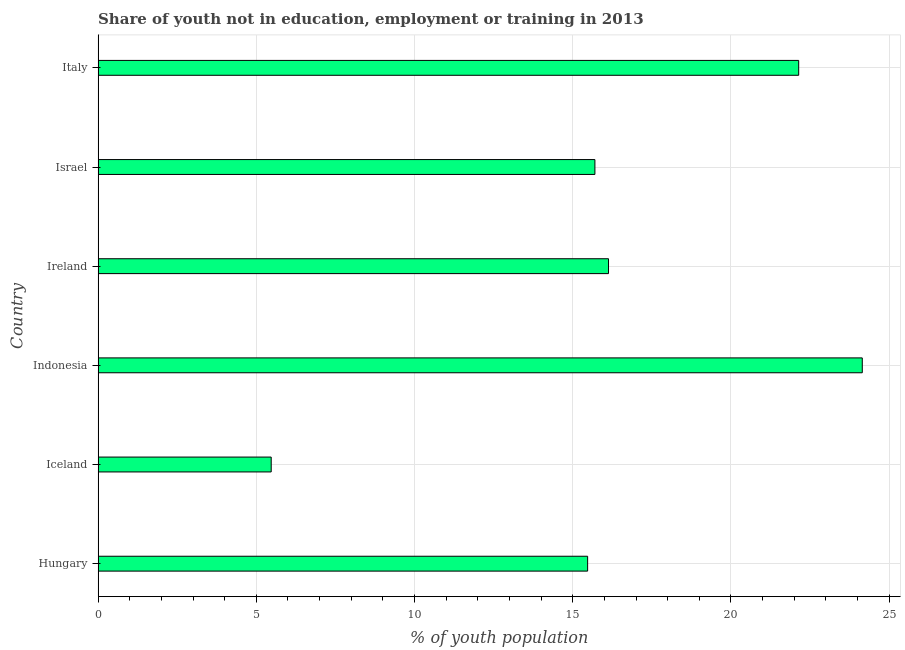What is the title of the graph?
Keep it short and to the point. Share of youth not in education, employment or training in 2013. What is the label or title of the X-axis?
Provide a succinct answer. % of youth population. What is the unemployed youth population in Italy?
Give a very brief answer. 22.14. Across all countries, what is the maximum unemployed youth population?
Your response must be concise. 24.15. Across all countries, what is the minimum unemployed youth population?
Give a very brief answer. 5.47. What is the sum of the unemployed youth population?
Keep it short and to the point. 99.06. What is the difference between the unemployed youth population in Indonesia and Italy?
Offer a terse response. 2.01. What is the average unemployed youth population per country?
Ensure brevity in your answer.  16.51. What is the median unemployed youth population?
Your answer should be very brief. 15.91. What is the ratio of the unemployed youth population in Ireland to that in Israel?
Your answer should be very brief. 1.03. Is the unemployed youth population in Hungary less than that in Indonesia?
Offer a very short reply. Yes. What is the difference between the highest and the second highest unemployed youth population?
Offer a very short reply. 2.01. What is the difference between the highest and the lowest unemployed youth population?
Your response must be concise. 18.68. Are all the bars in the graph horizontal?
Your answer should be compact. Yes. Are the values on the major ticks of X-axis written in scientific E-notation?
Your answer should be very brief. No. What is the % of youth population of Hungary?
Offer a very short reply. 15.47. What is the % of youth population of Iceland?
Your answer should be compact. 5.47. What is the % of youth population in Indonesia?
Provide a succinct answer. 24.15. What is the % of youth population in Ireland?
Offer a terse response. 16.13. What is the % of youth population in Israel?
Make the answer very short. 15.7. What is the % of youth population in Italy?
Your answer should be compact. 22.14. What is the difference between the % of youth population in Hungary and Iceland?
Provide a succinct answer. 10. What is the difference between the % of youth population in Hungary and Indonesia?
Provide a succinct answer. -8.68. What is the difference between the % of youth population in Hungary and Ireland?
Your response must be concise. -0.66. What is the difference between the % of youth population in Hungary and Israel?
Your answer should be compact. -0.23. What is the difference between the % of youth population in Hungary and Italy?
Offer a terse response. -6.67. What is the difference between the % of youth population in Iceland and Indonesia?
Your answer should be compact. -18.68. What is the difference between the % of youth population in Iceland and Ireland?
Give a very brief answer. -10.66. What is the difference between the % of youth population in Iceland and Israel?
Offer a terse response. -10.23. What is the difference between the % of youth population in Iceland and Italy?
Your answer should be compact. -16.67. What is the difference between the % of youth population in Indonesia and Ireland?
Your answer should be very brief. 8.02. What is the difference between the % of youth population in Indonesia and Israel?
Keep it short and to the point. 8.45. What is the difference between the % of youth population in Indonesia and Italy?
Provide a short and direct response. 2.01. What is the difference between the % of youth population in Ireland and Israel?
Make the answer very short. 0.43. What is the difference between the % of youth population in Ireland and Italy?
Keep it short and to the point. -6.01. What is the difference between the % of youth population in Israel and Italy?
Ensure brevity in your answer.  -6.44. What is the ratio of the % of youth population in Hungary to that in Iceland?
Keep it short and to the point. 2.83. What is the ratio of the % of youth population in Hungary to that in Indonesia?
Provide a short and direct response. 0.64. What is the ratio of the % of youth population in Hungary to that in Italy?
Keep it short and to the point. 0.7. What is the ratio of the % of youth population in Iceland to that in Indonesia?
Make the answer very short. 0.23. What is the ratio of the % of youth population in Iceland to that in Ireland?
Your answer should be compact. 0.34. What is the ratio of the % of youth population in Iceland to that in Israel?
Keep it short and to the point. 0.35. What is the ratio of the % of youth population in Iceland to that in Italy?
Ensure brevity in your answer.  0.25. What is the ratio of the % of youth population in Indonesia to that in Ireland?
Your answer should be compact. 1.5. What is the ratio of the % of youth population in Indonesia to that in Israel?
Provide a succinct answer. 1.54. What is the ratio of the % of youth population in Indonesia to that in Italy?
Keep it short and to the point. 1.09. What is the ratio of the % of youth population in Ireland to that in Israel?
Offer a terse response. 1.03. What is the ratio of the % of youth population in Ireland to that in Italy?
Offer a terse response. 0.73. What is the ratio of the % of youth population in Israel to that in Italy?
Your answer should be compact. 0.71. 